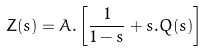<formula> <loc_0><loc_0><loc_500><loc_500>Z ( s ) = A . \left [ \frac { 1 } { 1 - s } + s . Q ( s ) \right ]</formula> 